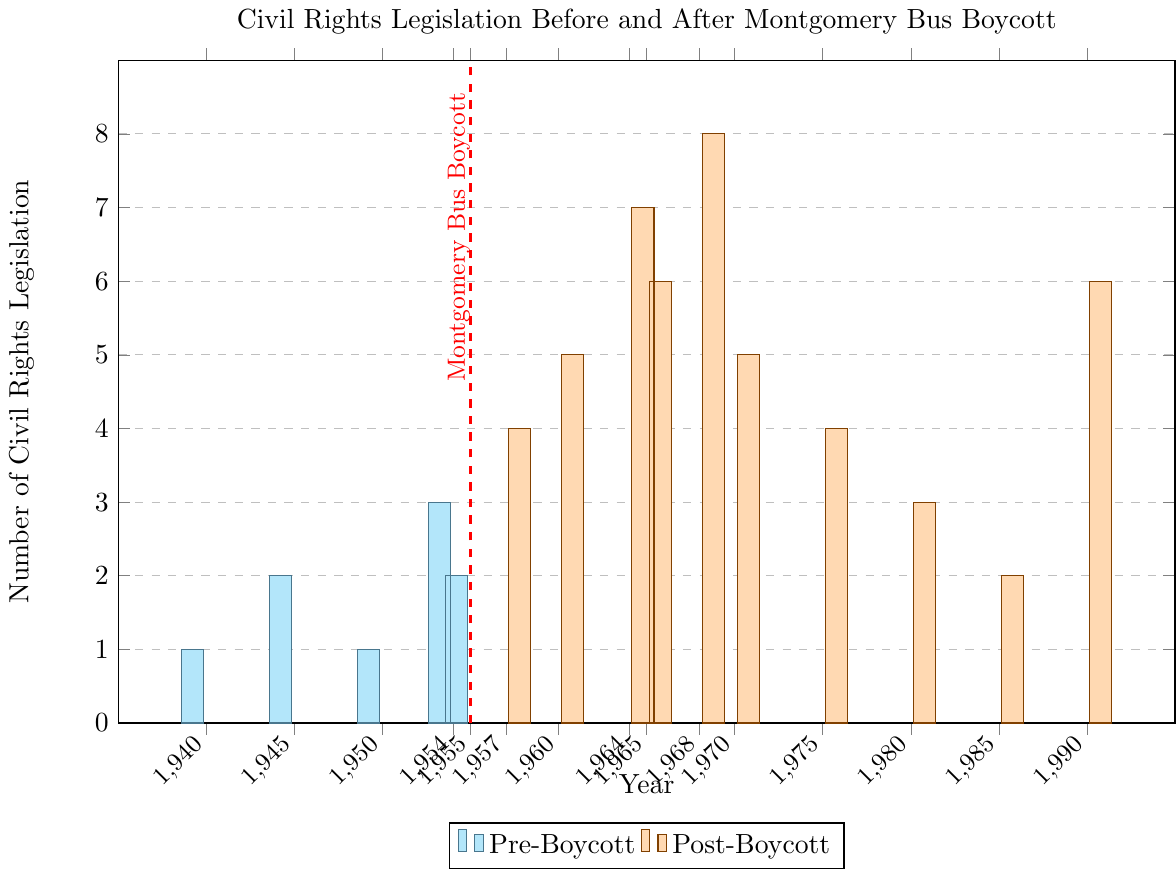What is the total number of civil rights legislation passed in the Pre-Boycott period? Add the number of legislations for the Pre-Boycott years: 1 (1940) + 2 (1945) + 1 (1950) + 3 (1954) + 2 (1955)
Answer: 9 Which year had the highest number of civil rights legislation passed in the Post-Boycott period? Identify the year with the tallest bar in the Post-Boycott period; 1968 has the highest value at 8
Answer: 1968 How does the number of civil rights legislation passed in 1964 compare to 1955? Compare the heights of the bars for 1964 (7) and 1955 (2); 1964 has more than 1955
Answer: 1964 has more What is the average number of civil rights legislation passed per year in the Post-Boycott period? Sum the number of legislations from 1957 to 1990 (4 + 5 + 7 + 6 + 8 + 5 + 4 + 3 + 2 + 6) and divide by the number of years (10); (4 + 5 + 7 + 6 + 8 + 5 + 4 + 3 + 2 + 6) / 10 = 50/10
Answer: 5 How many years after the Montgomery Bus Boycott did it take for the legislation count to first reach 7? Look for the first year in the Post-Boycott period where the bar height equals 7; 1964 is 9 years after 1955
Answer: 9 years In which year did civil rights legislation counts return to the level seen in 1945? Identify years when legislation count is 2; 1945 and 1985 both have a count of 2
Answer: 1985 Based on the figure, in which period were civil rights legislations passed more frequently? Sum the counts for both periods: Pre-Boycott (1+2+1+3+2 = 9) and Post-Boycott (4+5+7+6+8+5+4+3+2+6 = 50); 50 > 9
Answer: Post-Boycott What is the difference in the number of civil rights legislations passed between 1970 and 1950? Subtract the count for 1950 (1) from the count for 1970 (5); 5 - 1 = 4
Answer: 4 Which period has more variation in the number of legislations passed year-over-year? Compare the range for each period; Pre-Boycott range is 3-1 = 2, Post-Boycott range is 8-2 = 6; Post-Boycott has more variation
Answer: Post-Boycott 